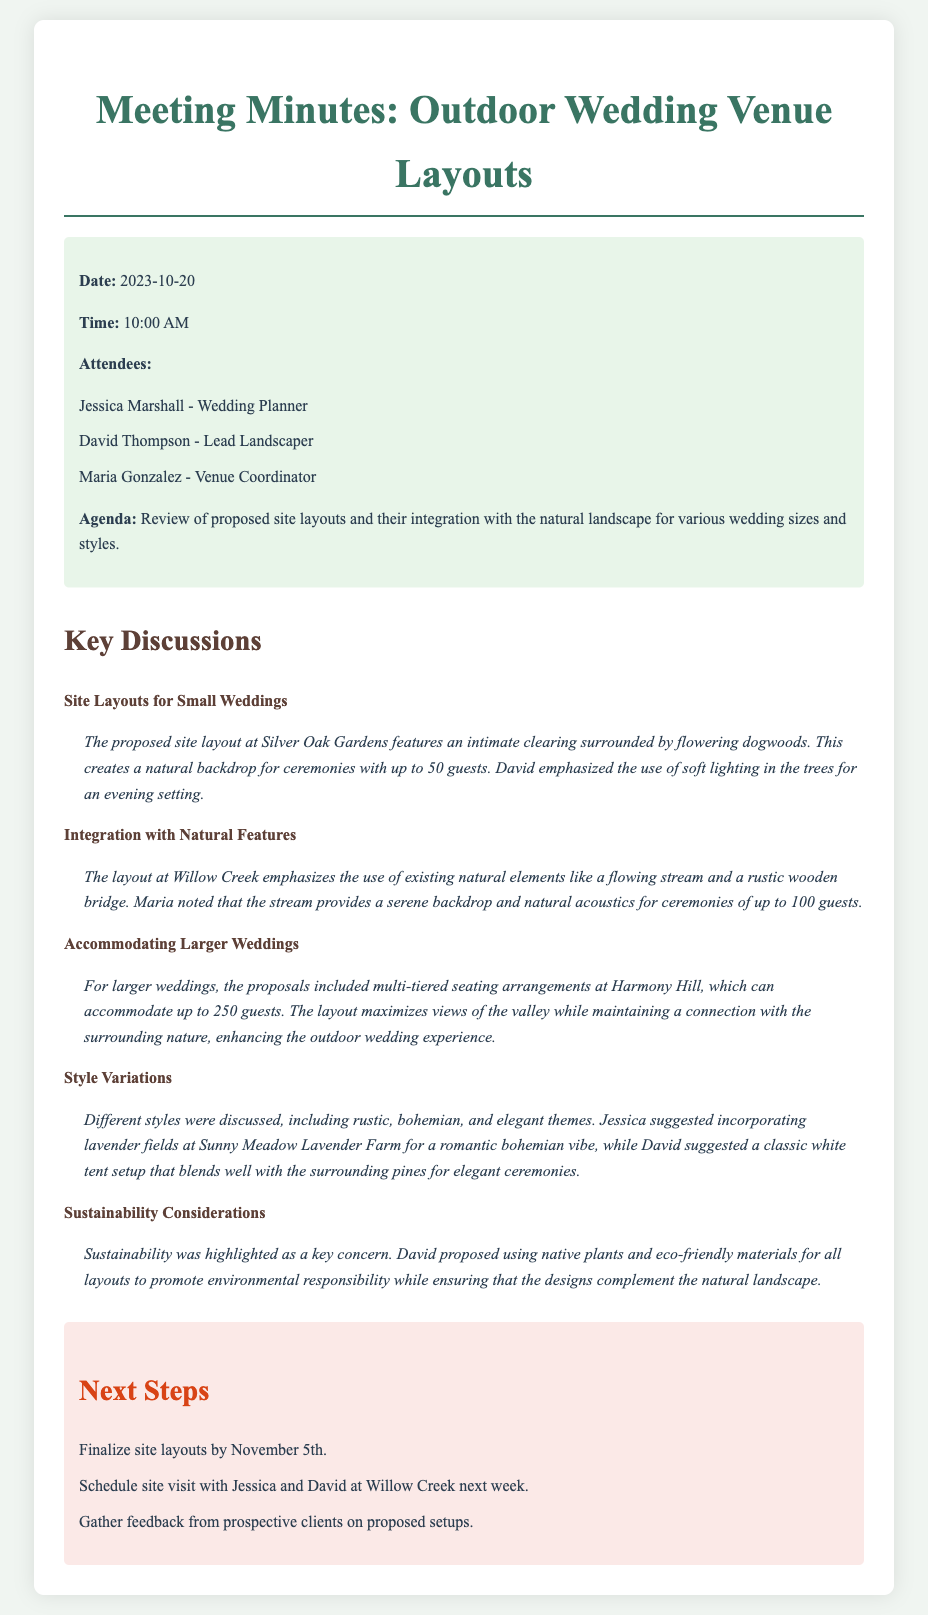what is the date of the meeting? The meeting took place on October 20, 2023.
Answer: October 20, 2023 who is the lead landscaper? The document identifies David Thompson as the lead landscaper present at the meeting.
Answer: David Thompson how many guests can Silver Oak Gardens accommodate? The layout at Silver Oak Gardens is designed for small weddings with a capacity of up to 50 guests.
Answer: 50 guests what style does Sunny Meadow Lavender Farm contribute to? The proposed use of lavender fields at Sunny Meadow Lavender Farm is aimed to create a romantic bohemian vibe.
Answer: bohemian what is a key consideration discussed in the meeting? Sustainability was highlighted as a key concern during the discussions at the meeting.
Answer: Sustainability what will happen by November 5th? The site layouts are to be finalized by November 5th as per the next steps section.
Answer: Finalize site layouts how many guests can Harmony Hill's layout accommodate? The proposed site layout at Harmony Hill can accommodate up to 250 guests.
Answer: 250 guests 